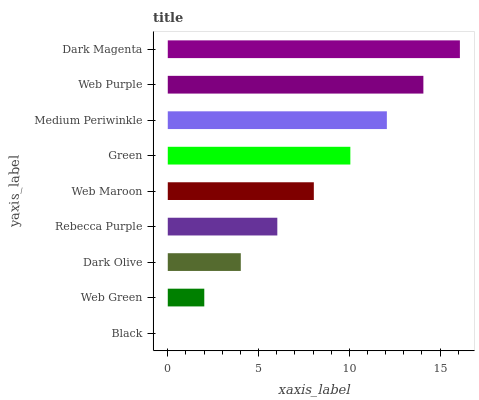Is Black the minimum?
Answer yes or no. Yes. Is Dark Magenta the maximum?
Answer yes or no. Yes. Is Web Green the minimum?
Answer yes or no. No. Is Web Green the maximum?
Answer yes or no. No. Is Web Green greater than Black?
Answer yes or no. Yes. Is Black less than Web Green?
Answer yes or no. Yes. Is Black greater than Web Green?
Answer yes or no. No. Is Web Green less than Black?
Answer yes or no. No. Is Web Maroon the high median?
Answer yes or no. Yes. Is Web Maroon the low median?
Answer yes or no. Yes. Is Rebecca Purple the high median?
Answer yes or no. No. Is Web Green the low median?
Answer yes or no. No. 